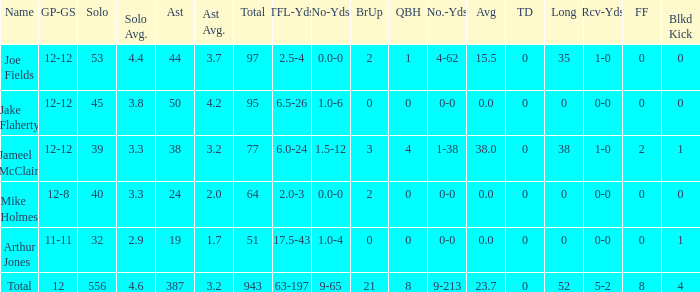What is the largest number of tds scored for a player? 0.0. 